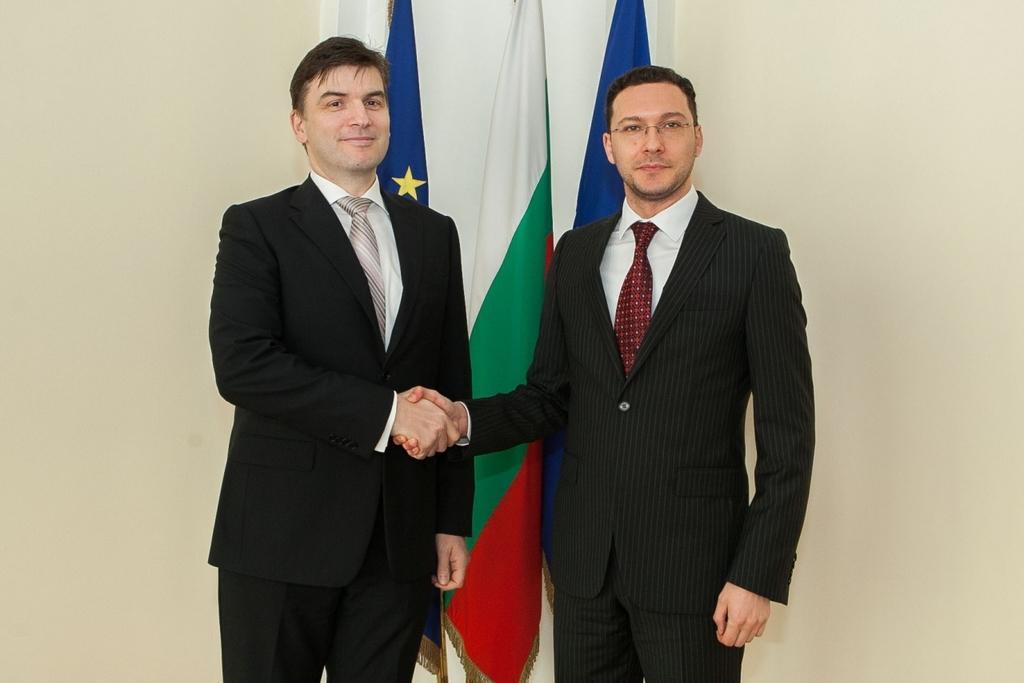Could you give a brief overview of what you see in this image? In the image there are two men, they are greeting each other and behind them there are three flags, in the background there is a wall. 